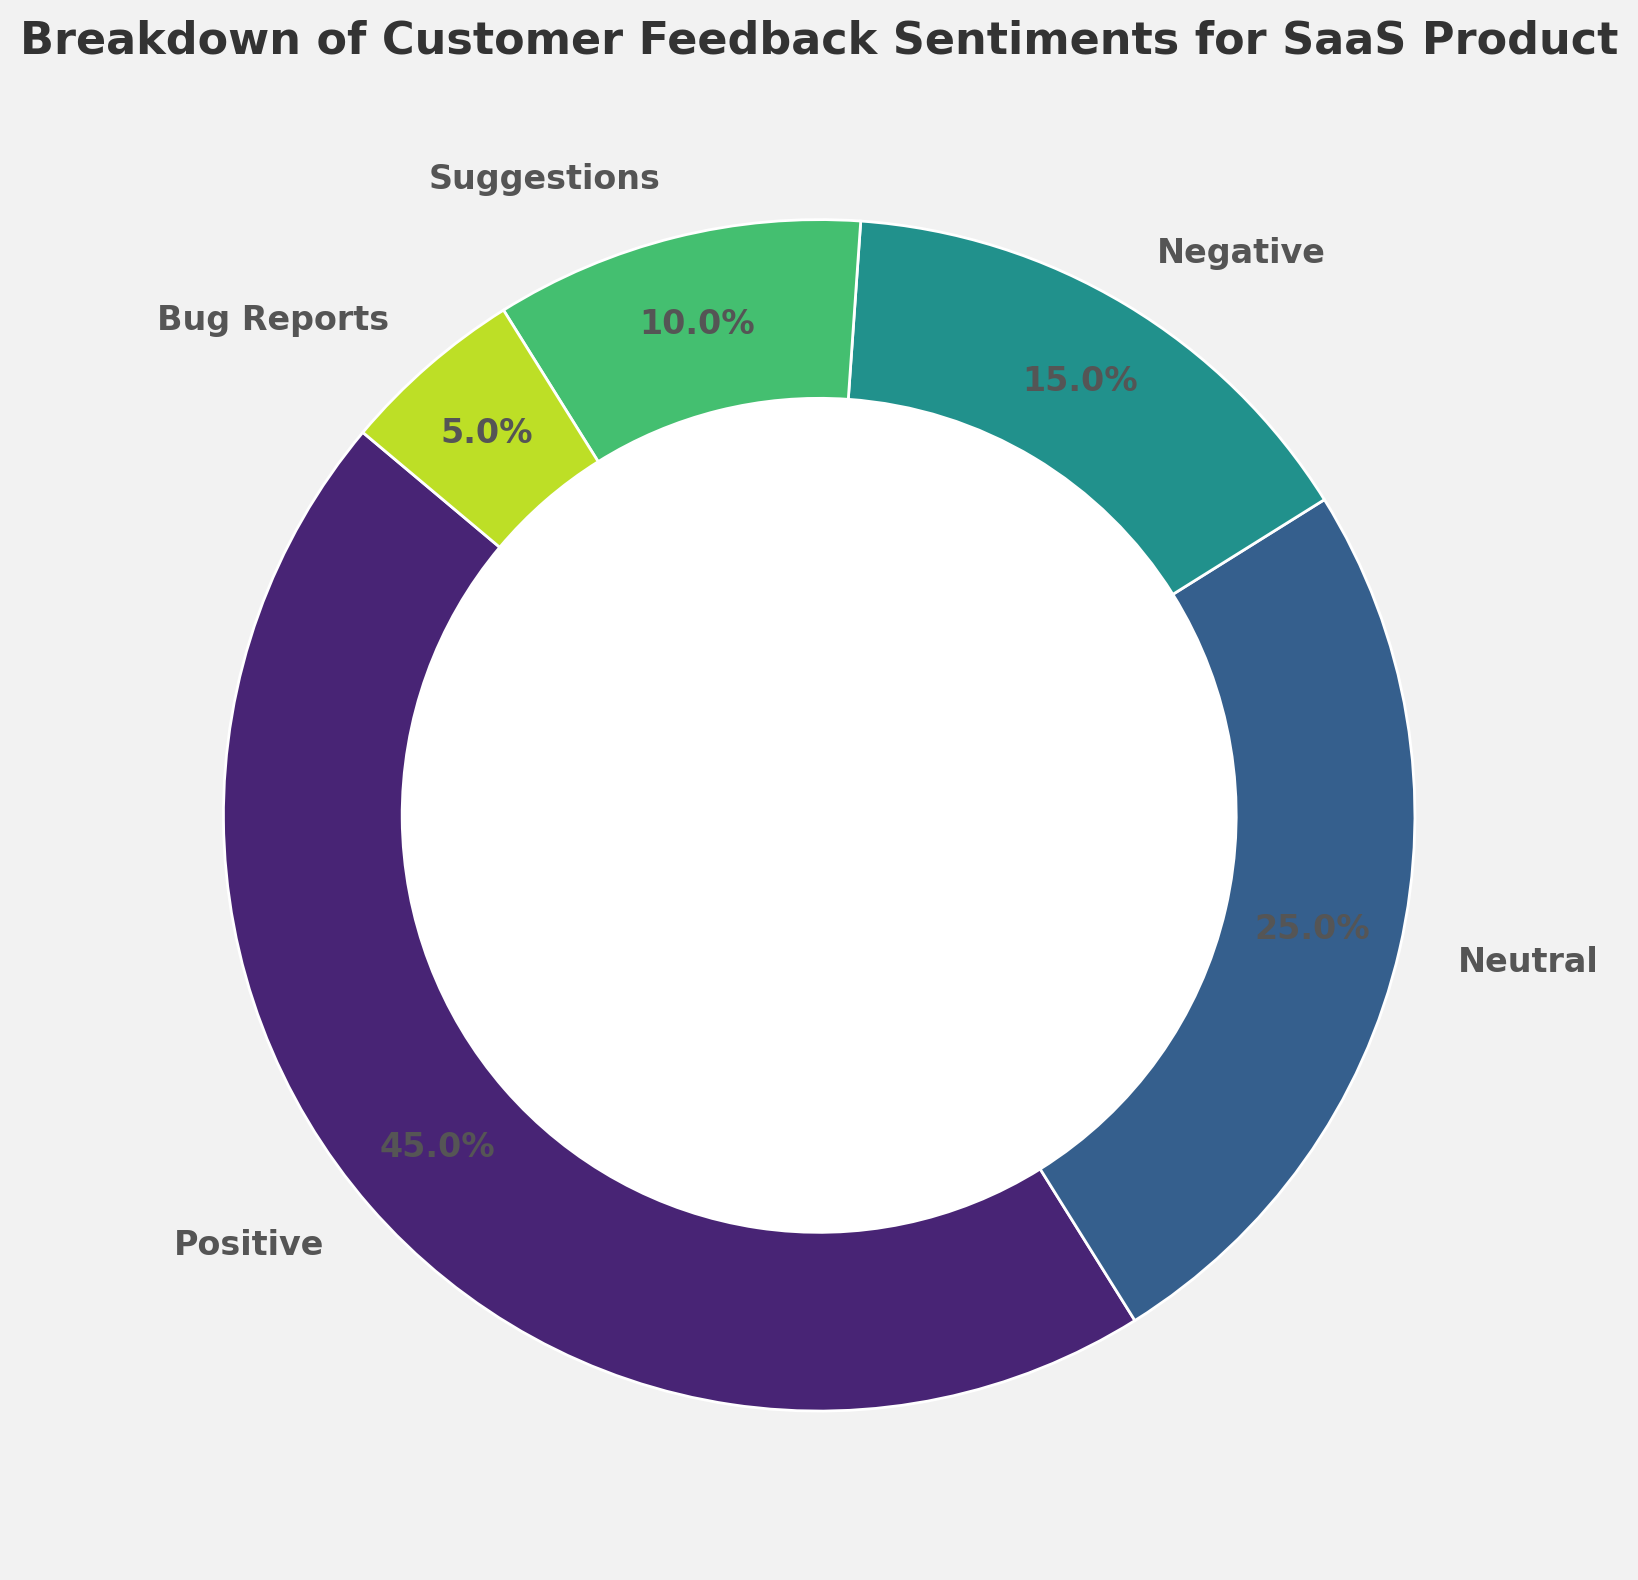What percentage of the feedback is either Neutral or Suggestions? Adding the percentages for Neutral (25%) and Suggestions (10%) gives us 25 + 10 = 35%
Answer: 35% Is the percentage of Positive feedback greater than the combined percentage of Negative and Bug Reports? The combined percentage of Negative (15%) and Bug Reports (5%) is 15 + 5 = 20%. Since Positive feedback is 45%, which is greater than 20%, the answer is yes.
Answer: Yes What is the smallest feedback category in terms of percentage? The smallest category, according to the chart, is Bug Reports which is 5%.
Answer: Bug Reports How much more percentage is Positive feedback compared to Negative feedback? We subtract the percentage of Negative feedback (15%) from Positive feedback (45%), giving us 45 - 15 = 30%
Answer: 30% Which category other than Positive feedback occupies the largest percentage of feedback? Besides Positive feedback, Neutral feedback occupies the next largest percentage at 25%.
Answer: Neutral What is the sum of the percentages for Negative feedback, Suggestions, and Bug Reports? Adding the percentages for Negative feedback (15%), Suggestions (10%), and Bug Reports (5%) gives us 15 + 10 + 5 = 30%
Answer: 30% If we were to group Positive and Neutral feedback together, what percentage of the total feedback would this group represent? Adding the percentages of Positive (45%) and Neutral (25%) feedback, we get 45 + 25 = 70%
Answer: 70% Which feedback category has a color closest to green in the chart? According to the design of the plot, where colors are sampled from the viridis colormap, Neutral feedback appears closer to green.
Answer: Neutral 